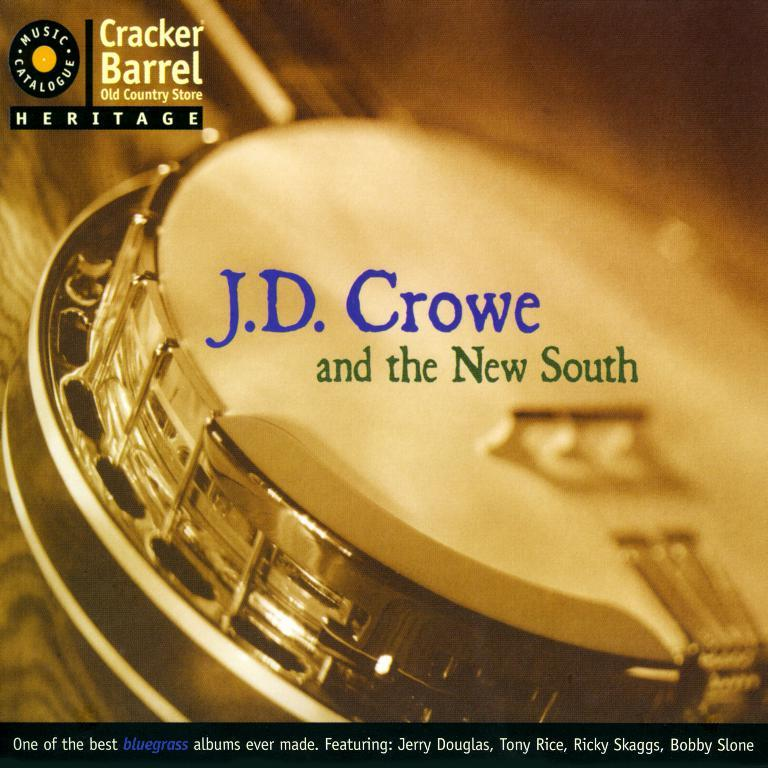<image>
Present a compact description of the photo's key features. A catalogue cover for Cracker Barrel Old Country Store features J.D. Crowe and the New South. 